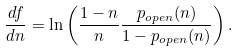Convert formula to latex. <formula><loc_0><loc_0><loc_500><loc_500>\frac { d f } { d n } = \ln \left ( \frac { 1 - n } { n } \frac { p _ { o p e n } ( n ) } { 1 - p _ { o p e n } ( n ) } \right ) .</formula> 